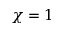Convert formula to latex. <formula><loc_0><loc_0><loc_500><loc_500>\chi = 1</formula> 